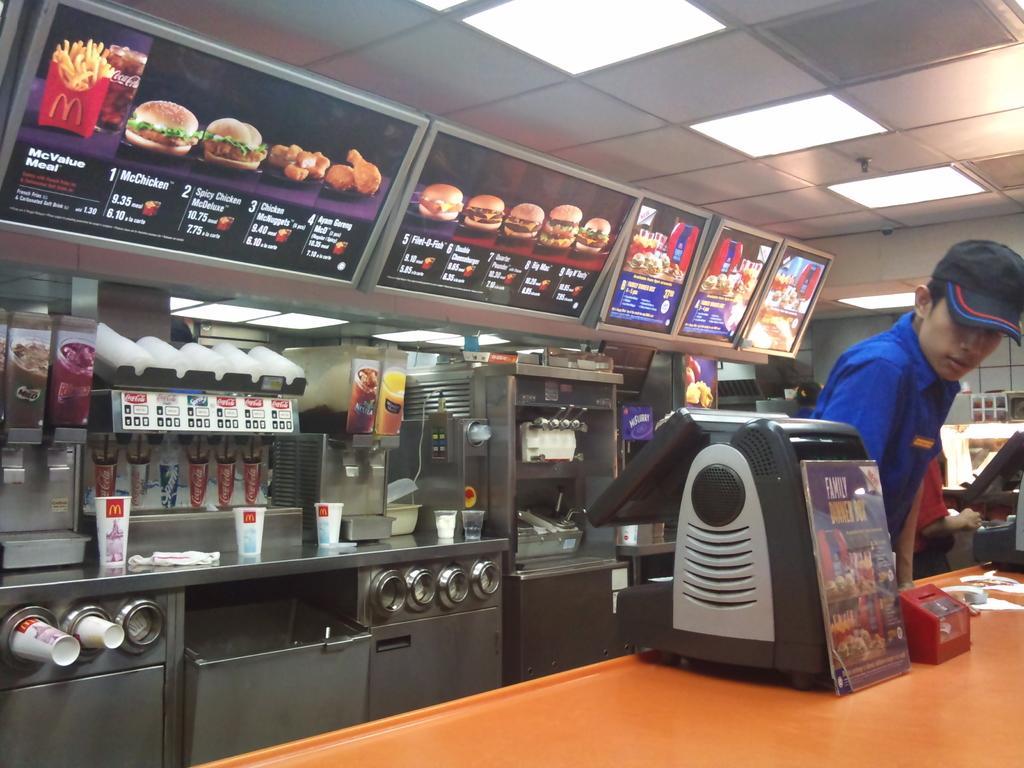In one or two sentences, can you explain what this image depicts? In this image we can see a person, he is wearing a cap, there is a soda fountain machine, there is an ice cream machine, there are cups, glasses, cabinets, there are some poster on the machines with images on it, there are screens with text and food images on it, there are monitors, and other electronic instruments on the table, also we can see the ceiling, and the lights. 